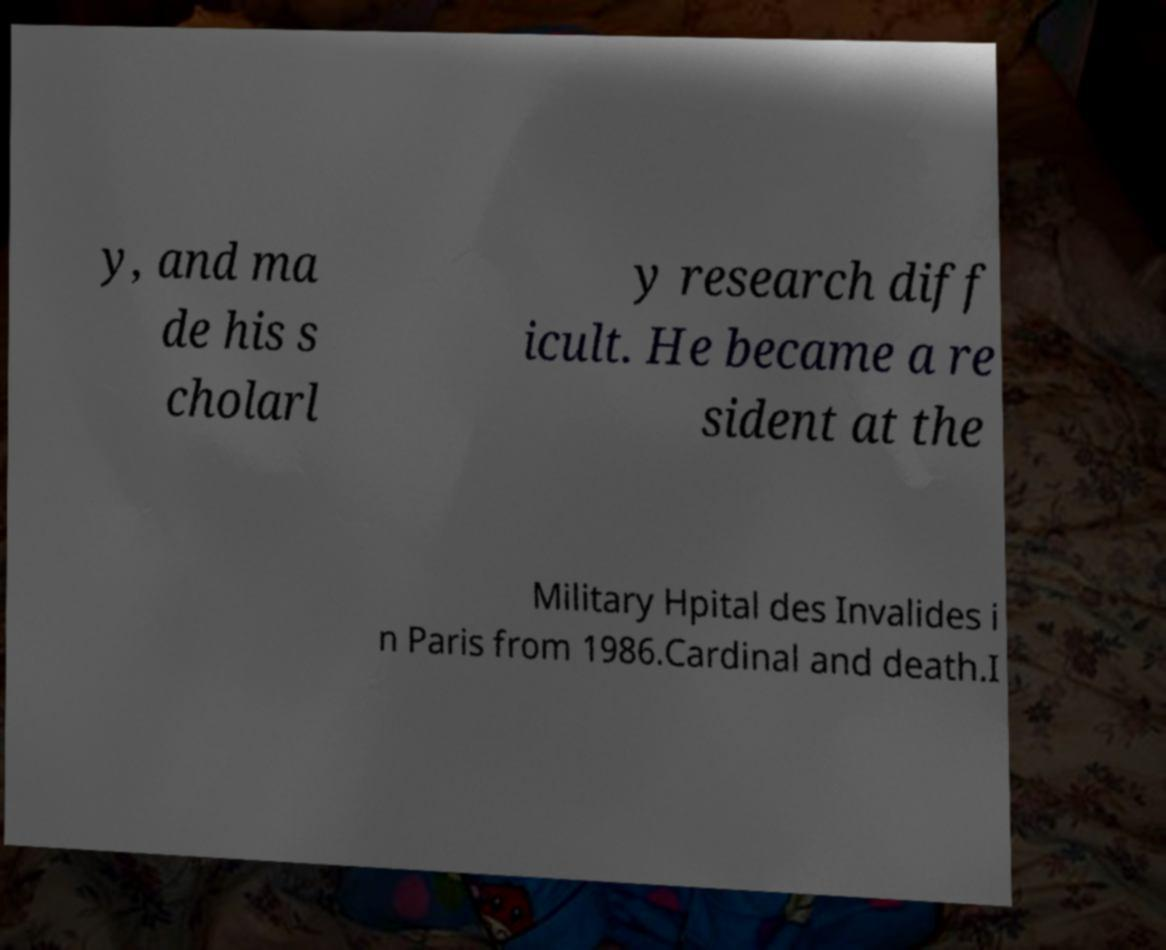Please read and relay the text visible in this image. What does it say? y, and ma de his s cholarl y research diff icult. He became a re sident at the Military Hpital des Invalides i n Paris from 1986.Cardinal and death.I 